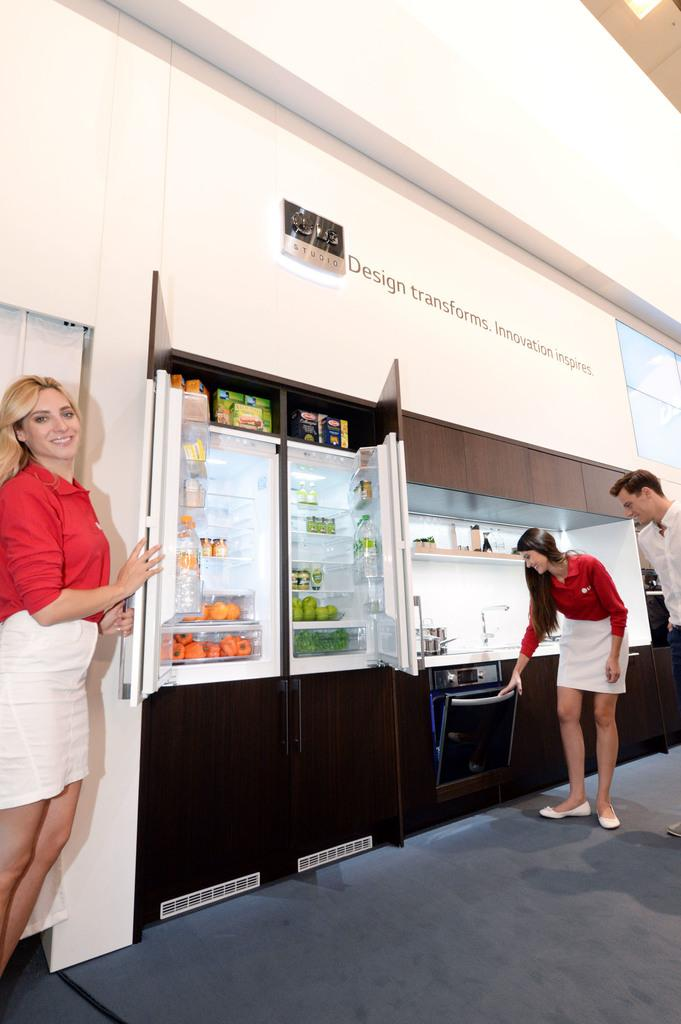<image>
Write a terse but informative summary of the picture. a sign above a fridge that says design transforms 